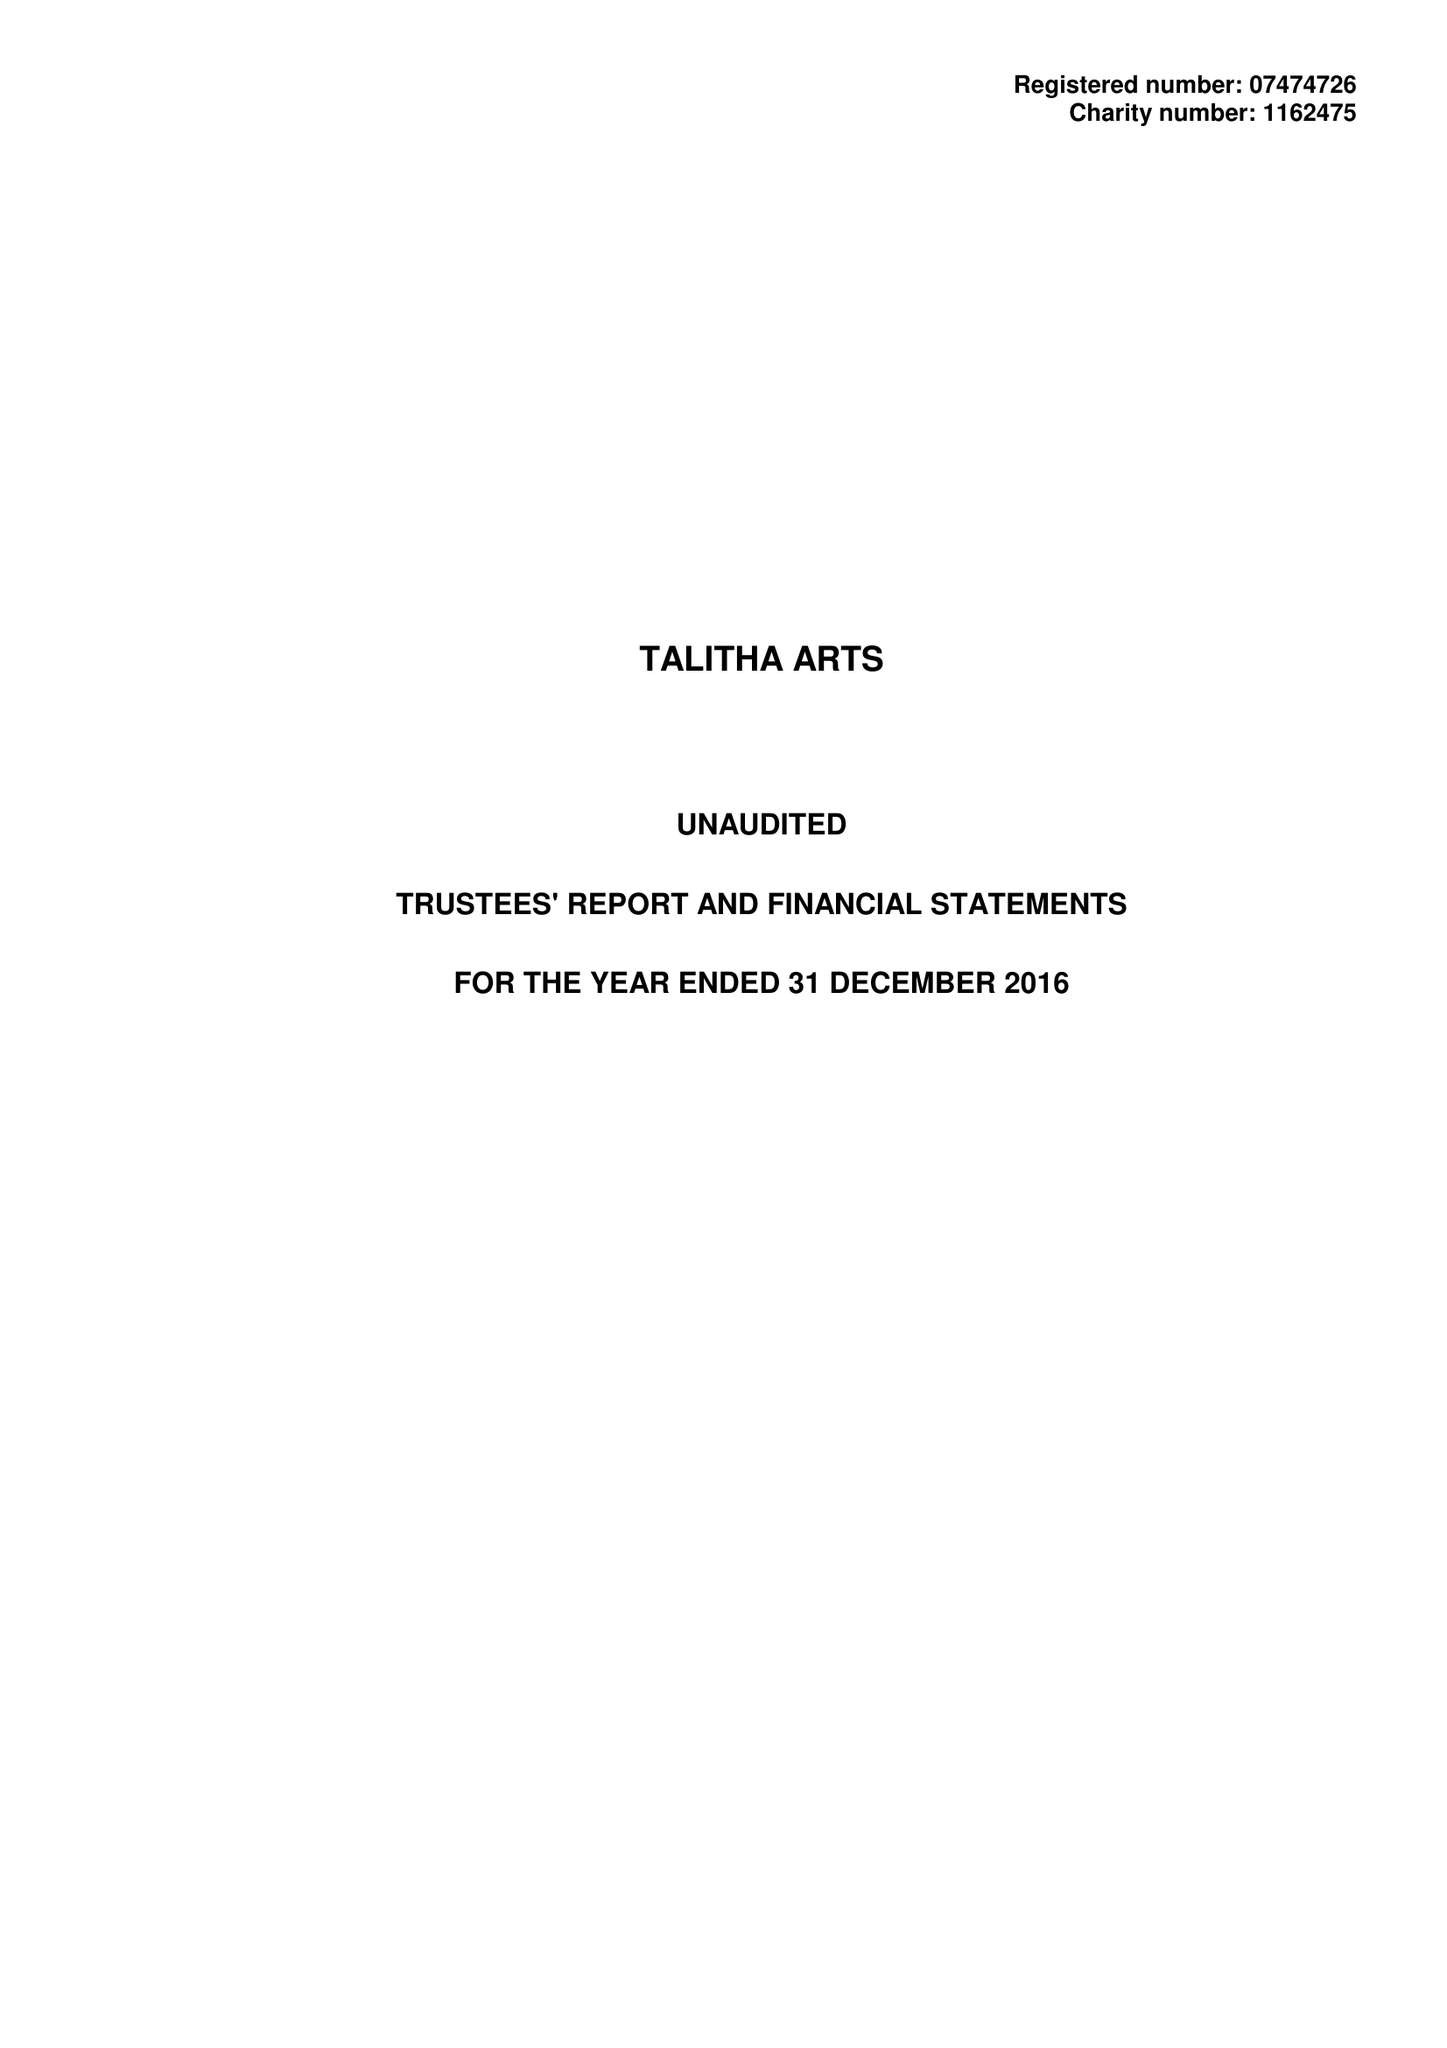What is the value for the address__street_line?
Answer the question using a single word or phrase. 5 CLARENCE ROAD 